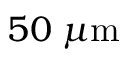<formula> <loc_0><loc_0><loc_500><loc_500>5 0 \, \mu m</formula> 